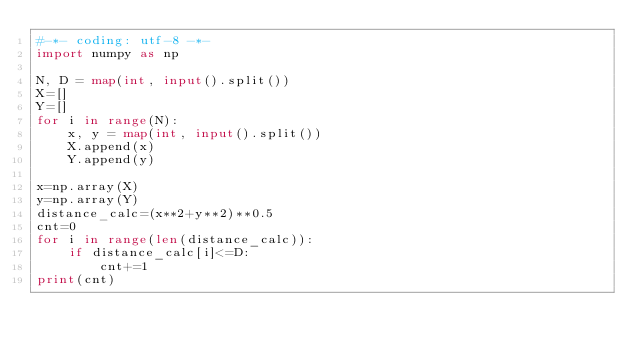<code> <loc_0><loc_0><loc_500><loc_500><_Python_>#-*- coding: utf-8 -*-
import numpy as np

N, D = map(int, input().split())
X=[]
Y=[]
for i in range(N):
    x, y = map(int, input().split())
    X.append(x)
    Y.append(y)

x=np.array(X)
y=np.array(Y)
distance_calc=(x**2+y**2)**0.5
cnt=0
for i in range(len(distance_calc)):
    if distance_calc[i]<=D:
        cnt+=1
print(cnt)</code> 